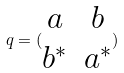Convert formula to latex. <formula><loc_0><loc_0><loc_500><loc_500>q = ( \begin{matrix} a & b \\ b ^ { * } & a ^ { * } \end{matrix} )</formula> 